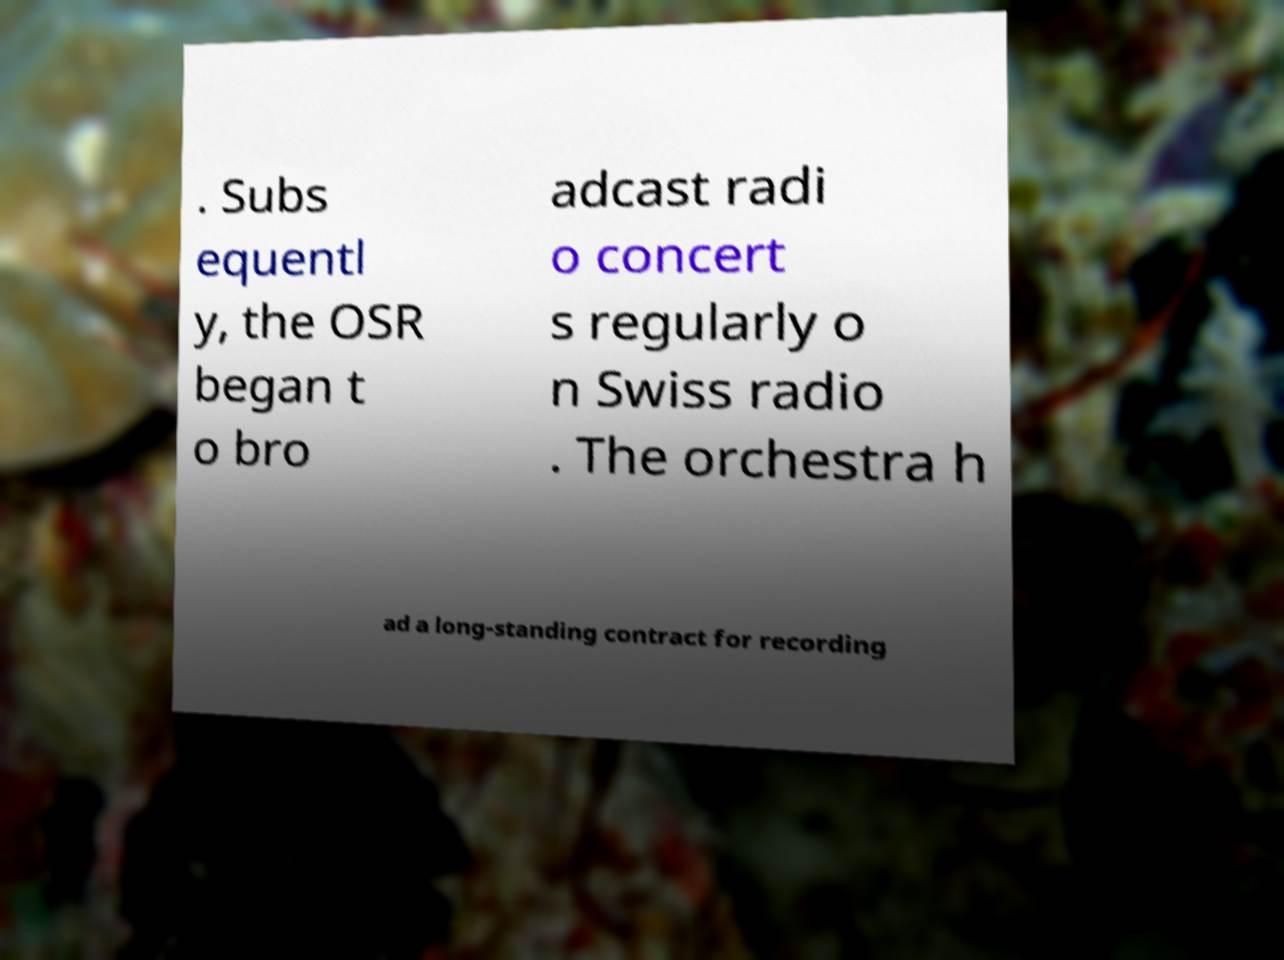For documentation purposes, I need the text within this image transcribed. Could you provide that? . Subs equentl y, the OSR began t o bro adcast radi o concert s regularly o n Swiss radio . The orchestra h ad a long-standing contract for recording 